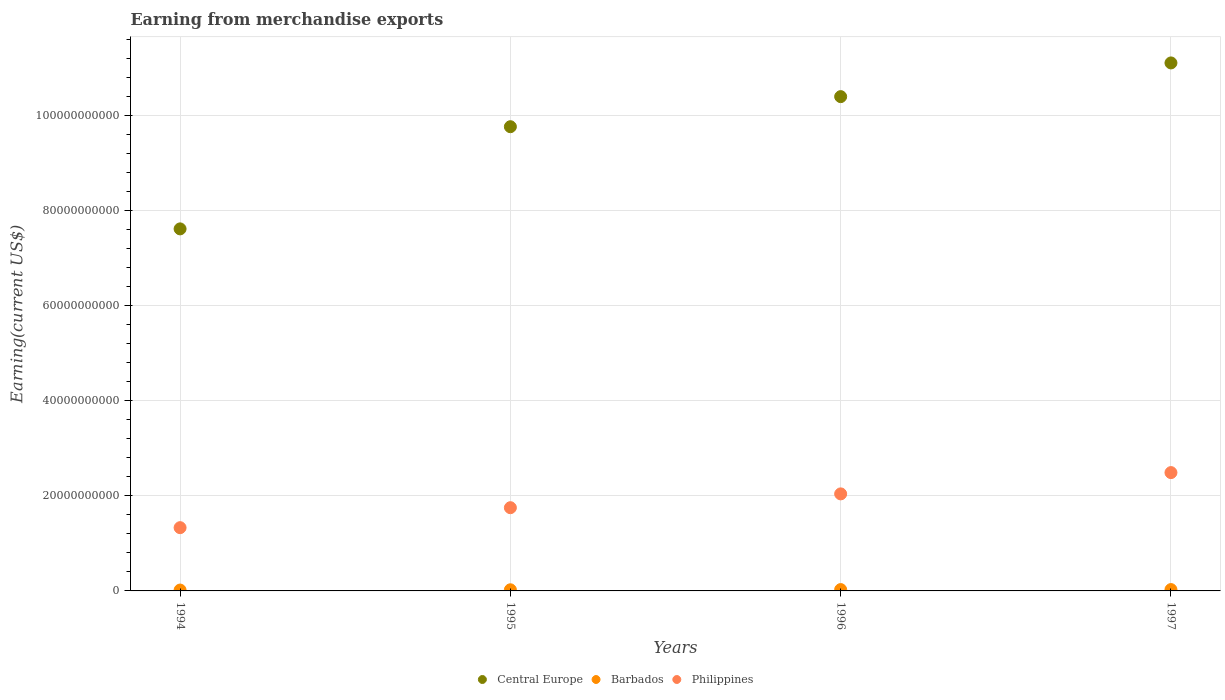How many different coloured dotlines are there?
Provide a succinct answer. 3. What is the amount earned from merchandise exports in Central Europe in 1994?
Keep it short and to the point. 7.61e+1. Across all years, what is the maximum amount earned from merchandise exports in Central Europe?
Your answer should be compact. 1.11e+11. Across all years, what is the minimum amount earned from merchandise exports in Barbados?
Offer a terse response. 1.82e+08. In which year was the amount earned from merchandise exports in Central Europe maximum?
Offer a terse response. 1997. What is the total amount earned from merchandise exports in Central Europe in the graph?
Make the answer very short. 3.89e+11. What is the difference between the amount earned from merchandise exports in Barbados in 1995 and that in 1997?
Offer a very short reply. -4.40e+07. What is the difference between the amount earned from merchandise exports in Philippines in 1994 and the amount earned from merchandise exports in Barbados in 1997?
Provide a short and direct response. 1.30e+1. What is the average amount earned from merchandise exports in Central Europe per year?
Offer a terse response. 9.72e+1. In the year 1996, what is the difference between the amount earned from merchandise exports in Barbados and amount earned from merchandise exports in Central Europe?
Make the answer very short. -1.04e+11. In how many years, is the amount earned from merchandise exports in Central Europe greater than 48000000000 US$?
Offer a terse response. 4. What is the ratio of the amount earned from merchandise exports in Central Europe in 1995 to that in 1996?
Your answer should be very brief. 0.94. Is the difference between the amount earned from merchandise exports in Barbados in 1994 and 1996 greater than the difference between the amount earned from merchandise exports in Central Europe in 1994 and 1996?
Give a very brief answer. Yes. What is the difference between the highest and the second highest amount earned from merchandise exports in Central Europe?
Offer a very short reply. 7.09e+09. What is the difference between the highest and the lowest amount earned from merchandise exports in Barbados?
Offer a very short reply. 1.01e+08. In how many years, is the amount earned from merchandise exports in Philippines greater than the average amount earned from merchandise exports in Philippines taken over all years?
Make the answer very short. 2. Is it the case that in every year, the sum of the amount earned from merchandise exports in Philippines and amount earned from merchandise exports in Central Europe  is greater than the amount earned from merchandise exports in Barbados?
Your answer should be very brief. Yes. Does the amount earned from merchandise exports in Central Europe monotonically increase over the years?
Ensure brevity in your answer.  Yes. Is the amount earned from merchandise exports in Philippines strictly greater than the amount earned from merchandise exports in Barbados over the years?
Give a very brief answer. Yes. Are the values on the major ticks of Y-axis written in scientific E-notation?
Give a very brief answer. No. Does the graph contain any zero values?
Offer a very short reply. No. Where does the legend appear in the graph?
Provide a short and direct response. Bottom center. How many legend labels are there?
Offer a very short reply. 3. How are the legend labels stacked?
Give a very brief answer. Horizontal. What is the title of the graph?
Provide a succinct answer. Earning from merchandise exports. Does "Uruguay" appear as one of the legend labels in the graph?
Your response must be concise. No. What is the label or title of the X-axis?
Provide a short and direct response. Years. What is the label or title of the Y-axis?
Your response must be concise. Earning(current US$). What is the Earning(current US$) in Central Europe in 1994?
Your answer should be compact. 7.61e+1. What is the Earning(current US$) of Barbados in 1994?
Your answer should be very brief. 1.82e+08. What is the Earning(current US$) of Philippines in 1994?
Give a very brief answer. 1.33e+1. What is the Earning(current US$) of Central Europe in 1995?
Ensure brevity in your answer.  9.76e+1. What is the Earning(current US$) in Barbados in 1995?
Keep it short and to the point. 2.39e+08. What is the Earning(current US$) of Philippines in 1995?
Provide a succinct answer. 1.75e+1. What is the Earning(current US$) in Central Europe in 1996?
Offer a terse response. 1.04e+11. What is the Earning(current US$) of Barbados in 1996?
Offer a terse response. 2.81e+08. What is the Earning(current US$) of Philippines in 1996?
Offer a terse response. 2.04e+1. What is the Earning(current US$) of Central Europe in 1997?
Your response must be concise. 1.11e+11. What is the Earning(current US$) of Barbados in 1997?
Provide a succinct answer. 2.83e+08. What is the Earning(current US$) in Philippines in 1997?
Offer a terse response. 2.49e+1. Across all years, what is the maximum Earning(current US$) in Central Europe?
Provide a succinct answer. 1.11e+11. Across all years, what is the maximum Earning(current US$) in Barbados?
Ensure brevity in your answer.  2.83e+08. Across all years, what is the maximum Earning(current US$) in Philippines?
Ensure brevity in your answer.  2.49e+1. Across all years, what is the minimum Earning(current US$) in Central Europe?
Give a very brief answer. 7.61e+1. Across all years, what is the minimum Earning(current US$) in Barbados?
Offer a terse response. 1.82e+08. Across all years, what is the minimum Earning(current US$) in Philippines?
Give a very brief answer. 1.33e+1. What is the total Earning(current US$) in Central Europe in the graph?
Offer a very short reply. 3.89e+11. What is the total Earning(current US$) of Barbados in the graph?
Provide a short and direct response. 9.85e+08. What is the total Earning(current US$) of Philippines in the graph?
Ensure brevity in your answer.  7.61e+1. What is the difference between the Earning(current US$) in Central Europe in 1994 and that in 1995?
Offer a terse response. -2.15e+1. What is the difference between the Earning(current US$) of Barbados in 1994 and that in 1995?
Offer a terse response. -5.70e+07. What is the difference between the Earning(current US$) in Philippines in 1994 and that in 1995?
Your answer should be very brief. -4.20e+09. What is the difference between the Earning(current US$) in Central Europe in 1994 and that in 1996?
Ensure brevity in your answer.  -2.78e+1. What is the difference between the Earning(current US$) in Barbados in 1994 and that in 1996?
Your answer should be very brief. -9.90e+07. What is the difference between the Earning(current US$) in Philippines in 1994 and that in 1996?
Offer a terse response. -7.10e+09. What is the difference between the Earning(current US$) in Central Europe in 1994 and that in 1997?
Your response must be concise. -3.49e+1. What is the difference between the Earning(current US$) of Barbados in 1994 and that in 1997?
Your answer should be very brief. -1.01e+08. What is the difference between the Earning(current US$) in Philippines in 1994 and that in 1997?
Make the answer very short. -1.16e+1. What is the difference between the Earning(current US$) of Central Europe in 1995 and that in 1996?
Offer a terse response. -6.33e+09. What is the difference between the Earning(current US$) of Barbados in 1995 and that in 1996?
Your answer should be very brief. -4.20e+07. What is the difference between the Earning(current US$) of Philippines in 1995 and that in 1996?
Provide a short and direct response. -2.91e+09. What is the difference between the Earning(current US$) of Central Europe in 1995 and that in 1997?
Provide a succinct answer. -1.34e+1. What is the difference between the Earning(current US$) of Barbados in 1995 and that in 1997?
Make the answer very short. -4.40e+07. What is the difference between the Earning(current US$) of Philippines in 1995 and that in 1997?
Offer a terse response. -7.38e+09. What is the difference between the Earning(current US$) of Central Europe in 1996 and that in 1997?
Provide a succinct answer. -7.09e+09. What is the difference between the Earning(current US$) in Barbados in 1996 and that in 1997?
Keep it short and to the point. -2.00e+06. What is the difference between the Earning(current US$) of Philippines in 1996 and that in 1997?
Your response must be concise. -4.47e+09. What is the difference between the Earning(current US$) in Central Europe in 1994 and the Earning(current US$) in Barbados in 1995?
Keep it short and to the point. 7.59e+1. What is the difference between the Earning(current US$) of Central Europe in 1994 and the Earning(current US$) of Philippines in 1995?
Ensure brevity in your answer.  5.86e+1. What is the difference between the Earning(current US$) in Barbados in 1994 and the Earning(current US$) in Philippines in 1995?
Your answer should be very brief. -1.73e+1. What is the difference between the Earning(current US$) in Central Europe in 1994 and the Earning(current US$) in Barbados in 1996?
Your answer should be very brief. 7.59e+1. What is the difference between the Earning(current US$) of Central Europe in 1994 and the Earning(current US$) of Philippines in 1996?
Your answer should be compact. 5.57e+1. What is the difference between the Earning(current US$) in Barbados in 1994 and the Earning(current US$) in Philippines in 1996?
Offer a terse response. -2.02e+1. What is the difference between the Earning(current US$) of Central Europe in 1994 and the Earning(current US$) of Barbados in 1997?
Offer a very short reply. 7.59e+1. What is the difference between the Earning(current US$) in Central Europe in 1994 and the Earning(current US$) in Philippines in 1997?
Keep it short and to the point. 5.13e+1. What is the difference between the Earning(current US$) in Barbados in 1994 and the Earning(current US$) in Philippines in 1997?
Ensure brevity in your answer.  -2.47e+1. What is the difference between the Earning(current US$) of Central Europe in 1995 and the Earning(current US$) of Barbados in 1996?
Make the answer very short. 9.73e+1. What is the difference between the Earning(current US$) of Central Europe in 1995 and the Earning(current US$) of Philippines in 1996?
Make the answer very short. 7.72e+1. What is the difference between the Earning(current US$) of Barbados in 1995 and the Earning(current US$) of Philippines in 1996?
Your answer should be compact. -2.02e+1. What is the difference between the Earning(current US$) of Central Europe in 1995 and the Earning(current US$) of Barbados in 1997?
Provide a succinct answer. 9.73e+1. What is the difference between the Earning(current US$) in Central Europe in 1995 and the Earning(current US$) in Philippines in 1997?
Provide a succinct answer. 7.27e+1. What is the difference between the Earning(current US$) in Barbados in 1995 and the Earning(current US$) in Philippines in 1997?
Offer a very short reply. -2.46e+1. What is the difference between the Earning(current US$) in Central Europe in 1996 and the Earning(current US$) in Barbados in 1997?
Ensure brevity in your answer.  1.04e+11. What is the difference between the Earning(current US$) of Central Europe in 1996 and the Earning(current US$) of Philippines in 1997?
Make the answer very short. 7.91e+1. What is the difference between the Earning(current US$) in Barbados in 1996 and the Earning(current US$) in Philippines in 1997?
Keep it short and to the point. -2.46e+1. What is the average Earning(current US$) in Central Europe per year?
Provide a succinct answer. 9.72e+1. What is the average Earning(current US$) in Barbados per year?
Offer a very short reply. 2.46e+08. What is the average Earning(current US$) in Philippines per year?
Make the answer very short. 1.90e+1. In the year 1994, what is the difference between the Earning(current US$) in Central Europe and Earning(current US$) in Barbados?
Offer a very short reply. 7.60e+1. In the year 1994, what is the difference between the Earning(current US$) of Central Europe and Earning(current US$) of Philippines?
Offer a very short reply. 6.28e+1. In the year 1994, what is the difference between the Earning(current US$) in Barbados and Earning(current US$) in Philippines?
Offer a terse response. -1.31e+1. In the year 1995, what is the difference between the Earning(current US$) in Central Europe and Earning(current US$) in Barbados?
Provide a short and direct response. 9.74e+1. In the year 1995, what is the difference between the Earning(current US$) in Central Europe and Earning(current US$) in Philippines?
Ensure brevity in your answer.  8.01e+1. In the year 1995, what is the difference between the Earning(current US$) of Barbados and Earning(current US$) of Philippines?
Your answer should be very brief. -1.73e+1. In the year 1996, what is the difference between the Earning(current US$) in Central Europe and Earning(current US$) in Barbados?
Provide a succinct answer. 1.04e+11. In the year 1996, what is the difference between the Earning(current US$) in Central Europe and Earning(current US$) in Philippines?
Your answer should be compact. 8.35e+1. In the year 1996, what is the difference between the Earning(current US$) of Barbados and Earning(current US$) of Philippines?
Provide a succinct answer. -2.01e+1. In the year 1997, what is the difference between the Earning(current US$) of Central Europe and Earning(current US$) of Barbados?
Your answer should be very brief. 1.11e+11. In the year 1997, what is the difference between the Earning(current US$) of Central Europe and Earning(current US$) of Philippines?
Offer a terse response. 8.62e+1. In the year 1997, what is the difference between the Earning(current US$) in Barbados and Earning(current US$) in Philippines?
Your answer should be compact. -2.46e+1. What is the ratio of the Earning(current US$) of Central Europe in 1994 to that in 1995?
Keep it short and to the point. 0.78. What is the ratio of the Earning(current US$) in Barbados in 1994 to that in 1995?
Keep it short and to the point. 0.76. What is the ratio of the Earning(current US$) of Philippines in 1994 to that in 1995?
Keep it short and to the point. 0.76. What is the ratio of the Earning(current US$) of Central Europe in 1994 to that in 1996?
Your answer should be compact. 0.73. What is the ratio of the Earning(current US$) in Barbados in 1994 to that in 1996?
Provide a succinct answer. 0.65. What is the ratio of the Earning(current US$) in Philippines in 1994 to that in 1996?
Offer a very short reply. 0.65. What is the ratio of the Earning(current US$) of Central Europe in 1994 to that in 1997?
Keep it short and to the point. 0.69. What is the ratio of the Earning(current US$) in Barbados in 1994 to that in 1997?
Give a very brief answer. 0.64. What is the ratio of the Earning(current US$) in Philippines in 1994 to that in 1997?
Your answer should be very brief. 0.53. What is the ratio of the Earning(current US$) of Central Europe in 1995 to that in 1996?
Your answer should be very brief. 0.94. What is the ratio of the Earning(current US$) in Barbados in 1995 to that in 1996?
Provide a succinct answer. 0.85. What is the ratio of the Earning(current US$) in Philippines in 1995 to that in 1996?
Provide a short and direct response. 0.86. What is the ratio of the Earning(current US$) of Central Europe in 1995 to that in 1997?
Provide a short and direct response. 0.88. What is the ratio of the Earning(current US$) in Barbados in 1995 to that in 1997?
Your response must be concise. 0.84. What is the ratio of the Earning(current US$) in Philippines in 1995 to that in 1997?
Your response must be concise. 0.7. What is the ratio of the Earning(current US$) of Central Europe in 1996 to that in 1997?
Keep it short and to the point. 0.94. What is the ratio of the Earning(current US$) of Philippines in 1996 to that in 1997?
Provide a succinct answer. 0.82. What is the difference between the highest and the second highest Earning(current US$) in Central Europe?
Your answer should be compact. 7.09e+09. What is the difference between the highest and the second highest Earning(current US$) of Barbados?
Ensure brevity in your answer.  2.00e+06. What is the difference between the highest and the second highest Earning(current US$) in Philippines?
Ensure brevity in your answer.  4.47e+09. What is the difference between the highest and the lowest Earning(current US$) in Central Europe?
Your response must be concise. 3.49e+1. What is the difference between the highest and the lowest Earning(current US$) of Barbados?
Offer a very short reply. 1.01e+08. What is the difference between the highest and the lowest Earning(current US$) in Philippines?
Make the answer very short. 1.16e+1. 